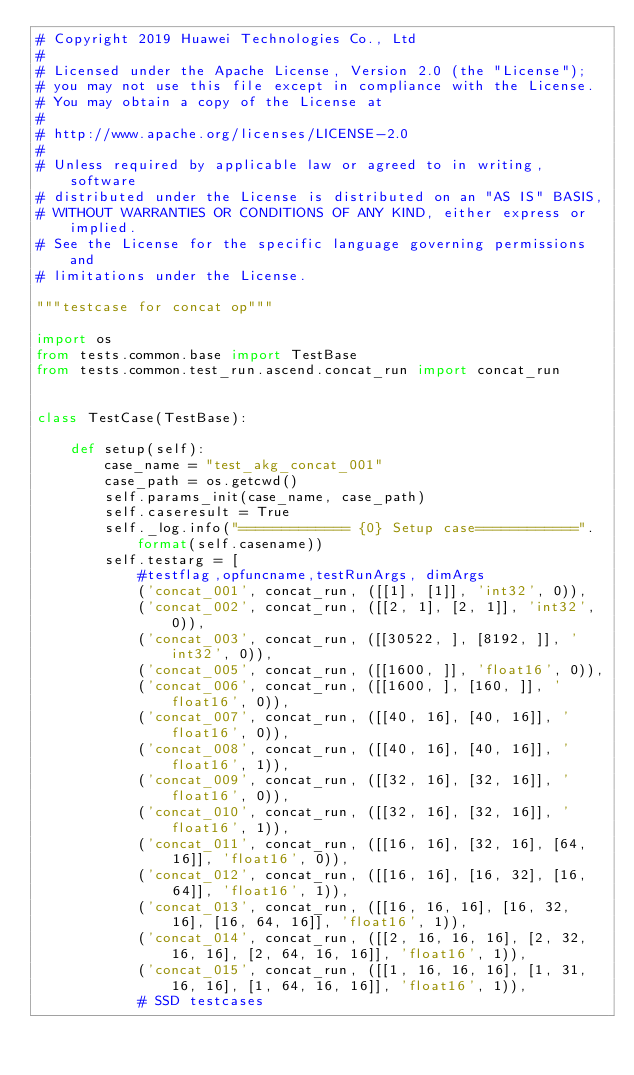Convert code to text. <code><loc_0><loc_0><loc_500><loc_500><_Python_># Copyright 2019 Huawei Technologies Co., Ltd
#
# Licensed under the Apache License, Version 2.0 (the "License");
# you may not use this file except in compliance with the License.
# You may obtain a copy of the License at
#
# http://www.apache.org/licenses/LICENSE-2.0
#
# Unless required by applicable law or agreed to in writing, software
# distributed under the License is distributed on an "AS IS" BASIS,
# WITHOUT WARRANTIES OR CONDITIONS OF ANY KIND, either express or implied.
# See the License for the specific language governing permissions and
# limitations under the License.

"""testcase for concat op"""

import os
from tests.common.base import TestBase
from tests.common.test_run.ascend.concat_run import concat_run


class TestCase(TestBase):

    def setup(self):
        case_name = "test_akg_concat_001"
        case_path = os.getcwd()
        self.params_init(case_name, case_path)
        self.caseresult = True
        self._log.info("============= {0} Setup case============".format(self.casename))
        self.testarg = [
            #testflag,opfuncname,testRunArgs, dimArgs
            ('concat_001', concat_run, ([[1], [1]], 'int32', 0)),
            ('concat_002', concat_run, ([[2, 1], [2, 1]], 'int32', 0)),
            ('concat_003', concat_run, ([[30522, ], [8192, ]], 'int32', 0)),
            ('concat_005', concat_run, ([[1600, ]], 'float16', 0)),
            ('concat_006', concat_run, ([[1600, ], [160, ]], 'float16', 0)),
            ('concat_007', concat_run, ([[40, 16], [40, 16]], 'float16', 0)),
            ('concat_008', concat_run, ([[40, 16], [40, 16]], 'float16', 1)),
            ('concat_009', concat_run, ([[32, 16], [32, 16]], 'float16', 0)),
            ('concat_010', concat_run, ([[32, 16], [32, 16]], 'float16', 1)),
            ('concat_011', concat_run, ([[16, 16], [32, 16], [64, 16]], 'float16', 0)),
            ('concat_012', concat_run, ([[16, 16], [16, 32], [16, 64]], 'float16', 1)),
            ('concat_013', concat_run, ([[16, 16, 16], [16, 32, 16], [16, 64, 16]], 'float16', 1)),
            ('concat_014', concat_run, ([[2, 16, 16, 16], [2, 32, 16, 16], [2, 64, 16, 16]], 'float16', 1)),
            ('concat_015', concat_run, ([[1, 16, 16, 16], [1, 31, 16, 16], [1, 64, 16, 16]], 'float16', 1)),
            # SSD testcases</code> 